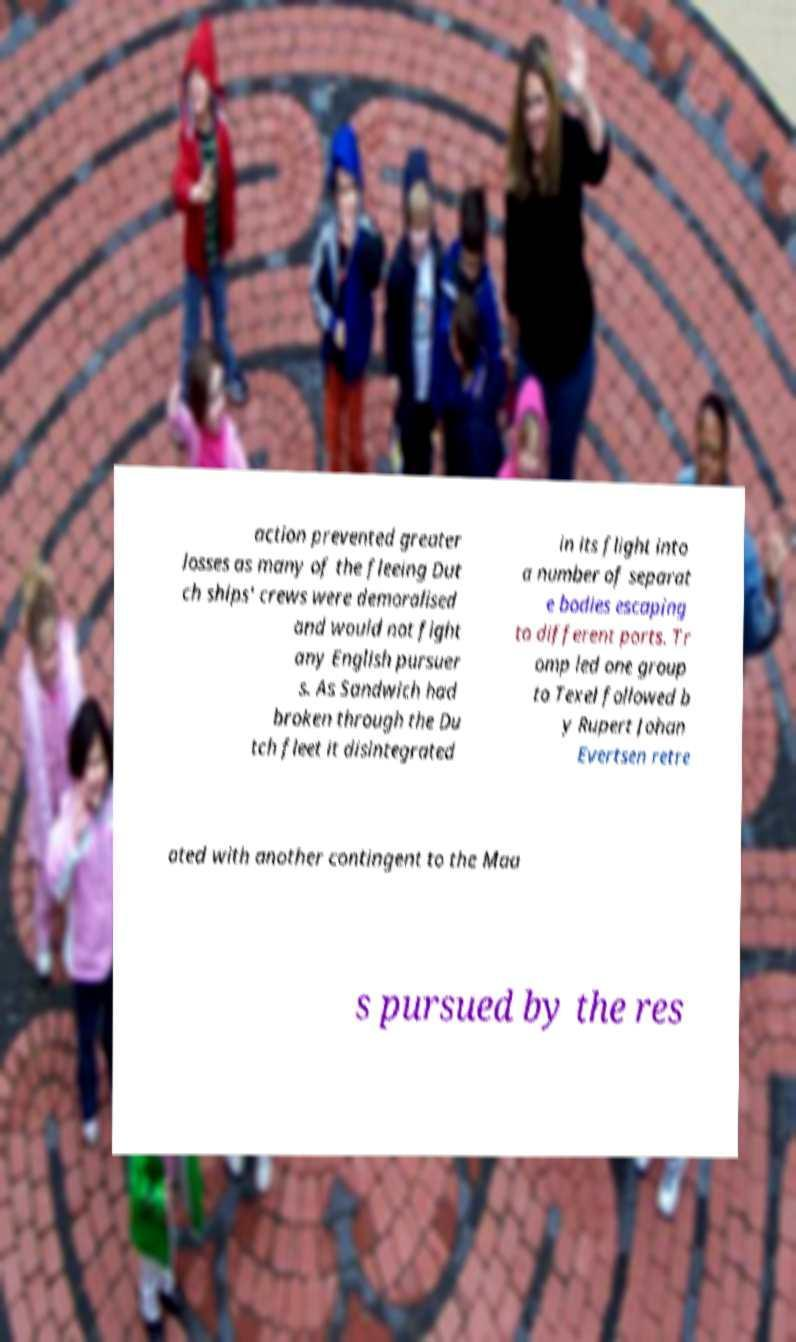Can you read and provide the text displayed in the image?This photo seems to have some interesting text. Can you extract and type it out for me? action prevented greater losses as many of the fleeing Dut ch ships' crews were demoralised and would not fight any English pursuer s. As Sandwich had broken through the Du tch fleet it disintegrated in its flight into a number of separat e bodies escaping to different ports. Tr omp led one group to Texel followed b y Rupert Johan Evertsen retre ated with another contingent to the Maa s pursued by the res 